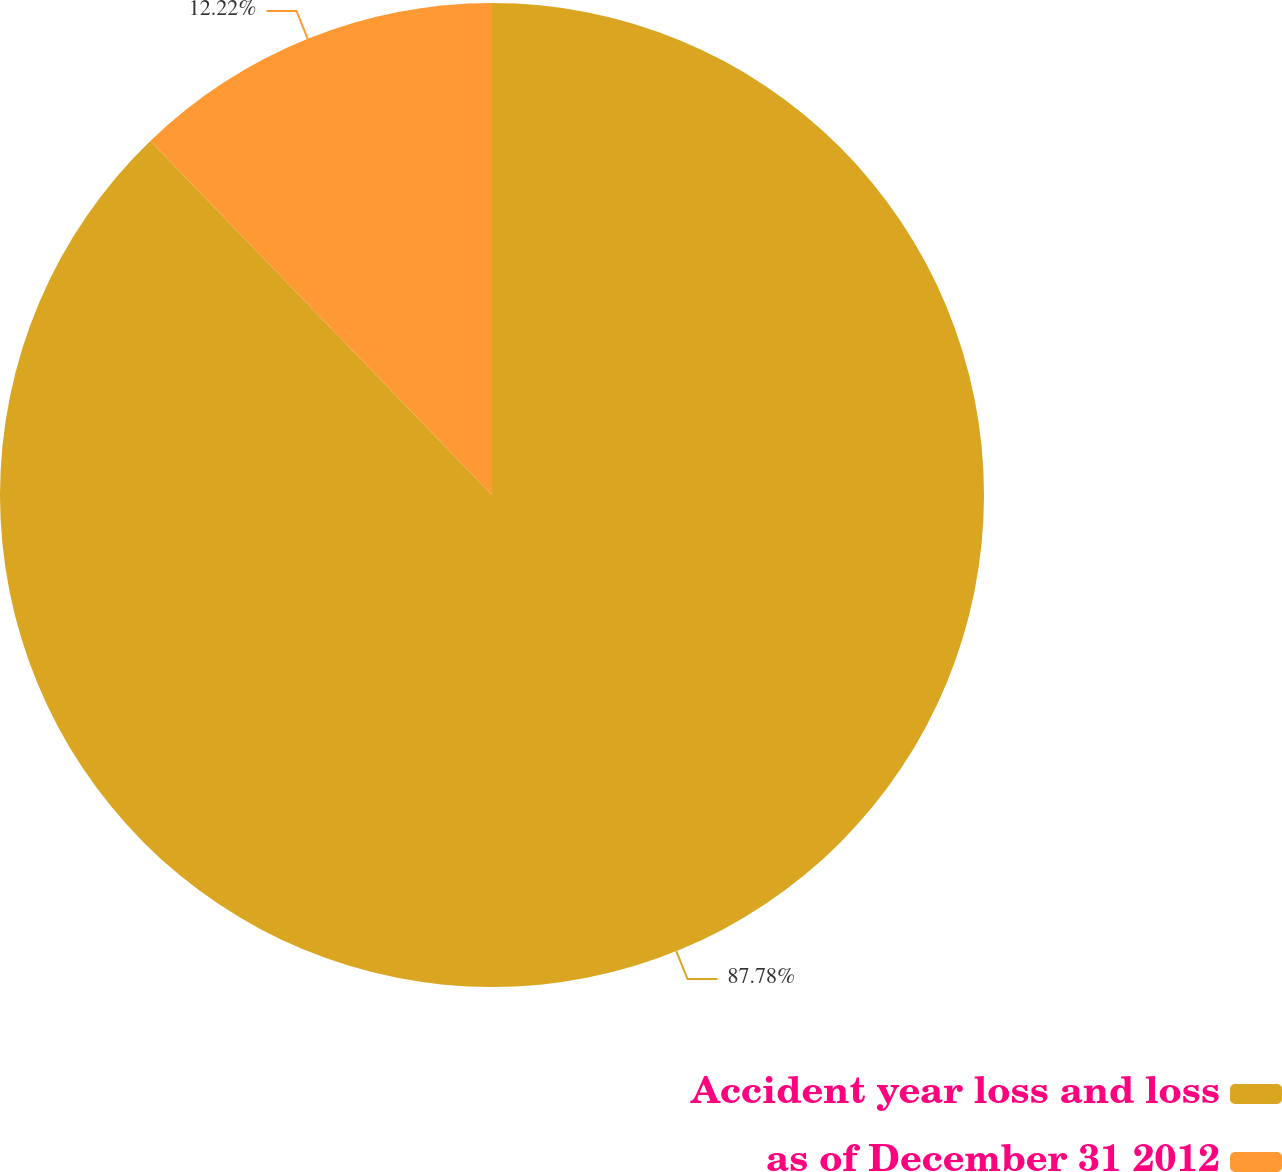Convert chart to OTSL. <chart><loc_0><loc_0><loc_500><loc_500><pie_chart><fcel>Accident year loss and loss<fcel>as of December 31 2012<nl><fcel>87.78%<fcel>12.22%<nl></chart> 